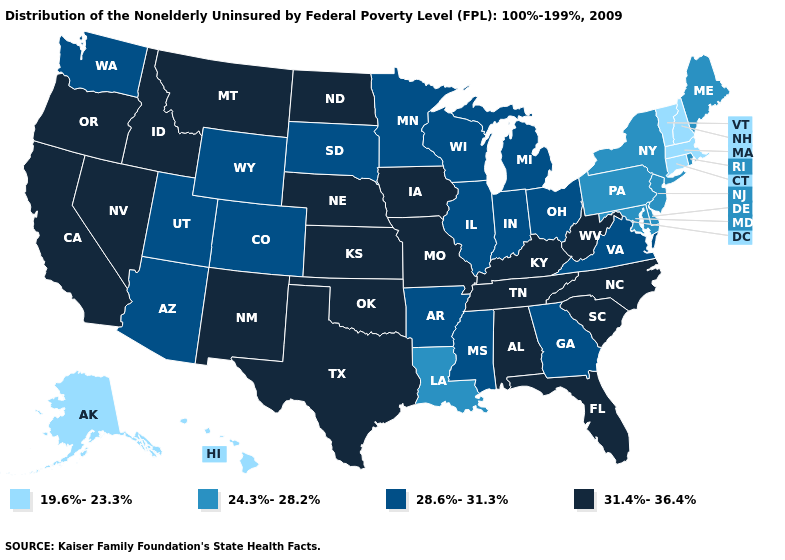What is the highest value in states that border Kentucky?
Give a very brief answer. 31.4%-36.4%. What is the value of Montana?
Short answer required. 31.4%-36.4%. Name the states that have a value in the range 19.6%-23.3%?
Write a very short answer. Alaska, Connecticut, Hawaii, Massachusetts, New Hampshire, Vermont. Which states have the lowest value in the West?
Answer briefly. Alaska, Hawaii. What is the highest value in the USA?
Short answer required. 31.4%-36.4%. Which states have the lowest value in the USA?
Give a very brief answer. Alaska, Connecticut, Hawaii, Massachusetts, New Hampshire, Vermont. Does Rhode Island have the highest value in the Northeast?
Write a very short answer. Yes. Does Utah have a higher value than Pennsylvania?
Write a very short answer. Yes. Among the states that border Montana , does Idaho have the highest value?
Write a very short answer. Yes. Name the states that have a value in the range 24.3%-28.2%?
Quick response, please. Delaware, Louisiana, Maine, Maryland, New Jersey, New York, Pennsylvania, Rhode Island. Name the states that have a value in the range 28.6%-31.3%?
Write a very short answer. Arizona, Arkansas, Colorado, Georgia, Illinois, Indiana, Michigan, Minnesota, Mississippi, Ohio, South Dakota, Utah, Virginia, Washington, Wisconsin, Wyoming. What is the value of Ohio?
Write a very short answer. 28.6%-31.3%. What is the value of Maine?
Short answer required. 24.3%-28.2%. Is the legend a continuous bar?
Short answer required. No. Does West Virginia have the highest value in the USA?
Be succinct. Yes. 